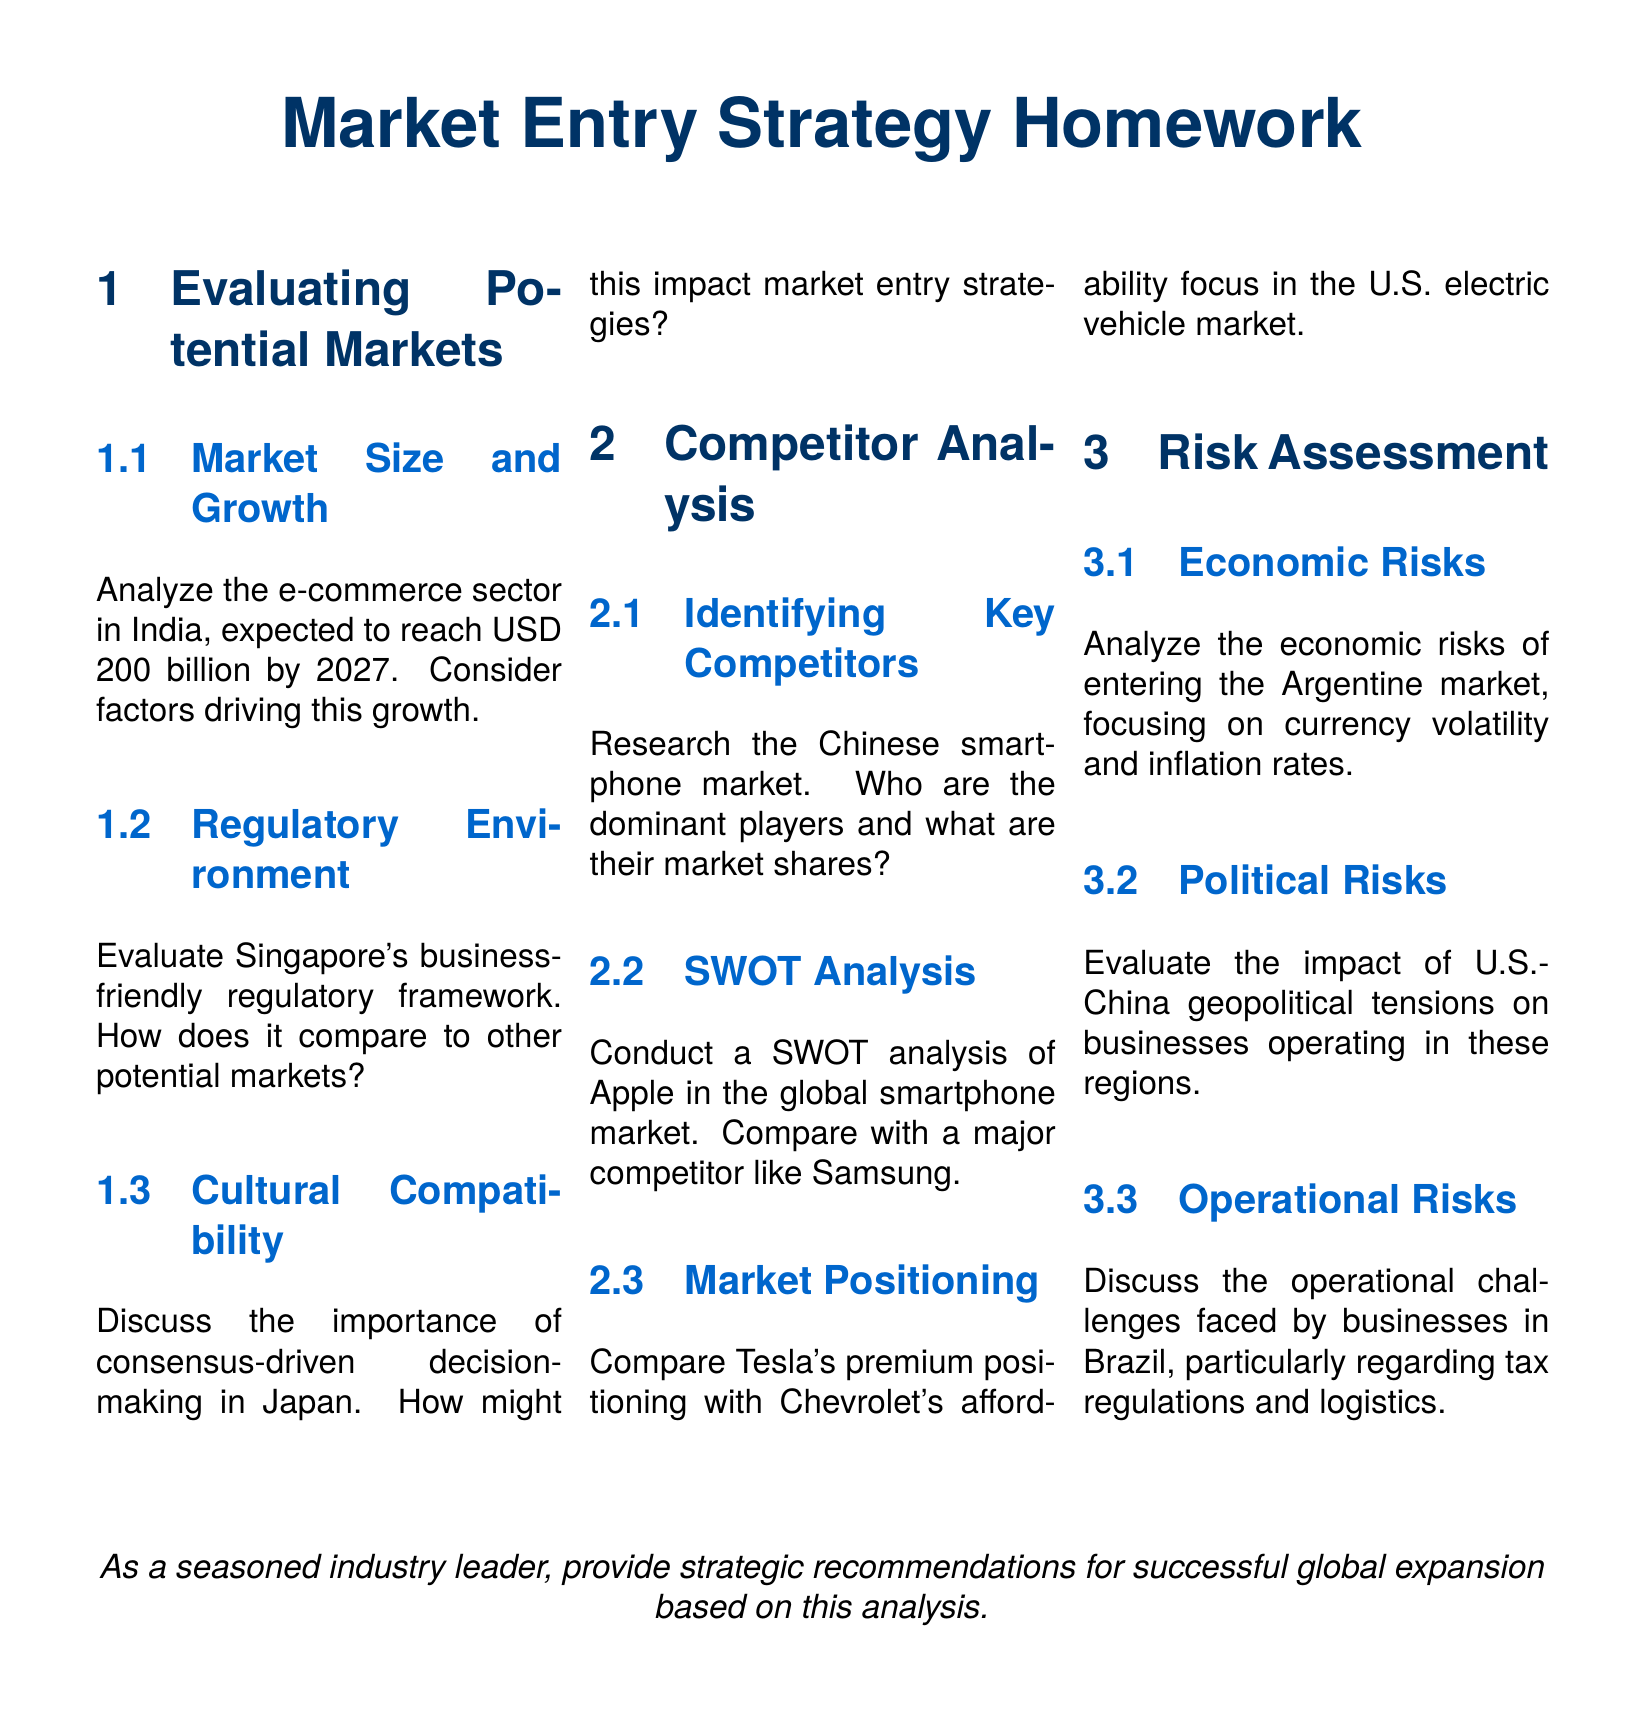what is the expected market size of e-commerce in India by 2027? The document states that the e-commerce sector in India is expected to reach USD 200 billion by 2027.
Answer: USD 200 billion what is Singapore known for in terms of market entry? The document evaluates Singapore's business-friendly regulatory framework in comparison to other potential markets.
Answer: Business-friendly regulatory framework what decision-making style is emphasized in Japan? The document discusses the importance of consensus-driven decision-making in Japan.
Answer: Consensus-driven who are the dominant players in the Chinese smartphone market? The document specifies the need to identify key competitors within the Chinese smartphone market.
Answer: Dominant players who is a major competitor of Apple in the global smartphone market? The document mentions Samsung as a major competitor in the SWOT analysis section for Apple.
Answer: Samsung what is the currency situation analyzed for the Argentine market? The document highlights currency volatility as an economic risk for entering the Argentine market.
Answer: Currency volatility what geopolitical issue is linked to U.S.-China business operations? The document evaluates the impact of U.S.-China geopolitical tensions on businesses in these regions.
Answer: U.S.-China geopolitical tensions what operational challenges are noted for businesses in Brazil? The document discusses tax regulations and logistics as operational challenges faced by businesses in Brazil.
Answer: Tax regulations and logistics what type of strategies are being sought in the final section of the document? The last part of the document requests strategic recommendations for successful global expansion.
Answer: Strategic recommendations 